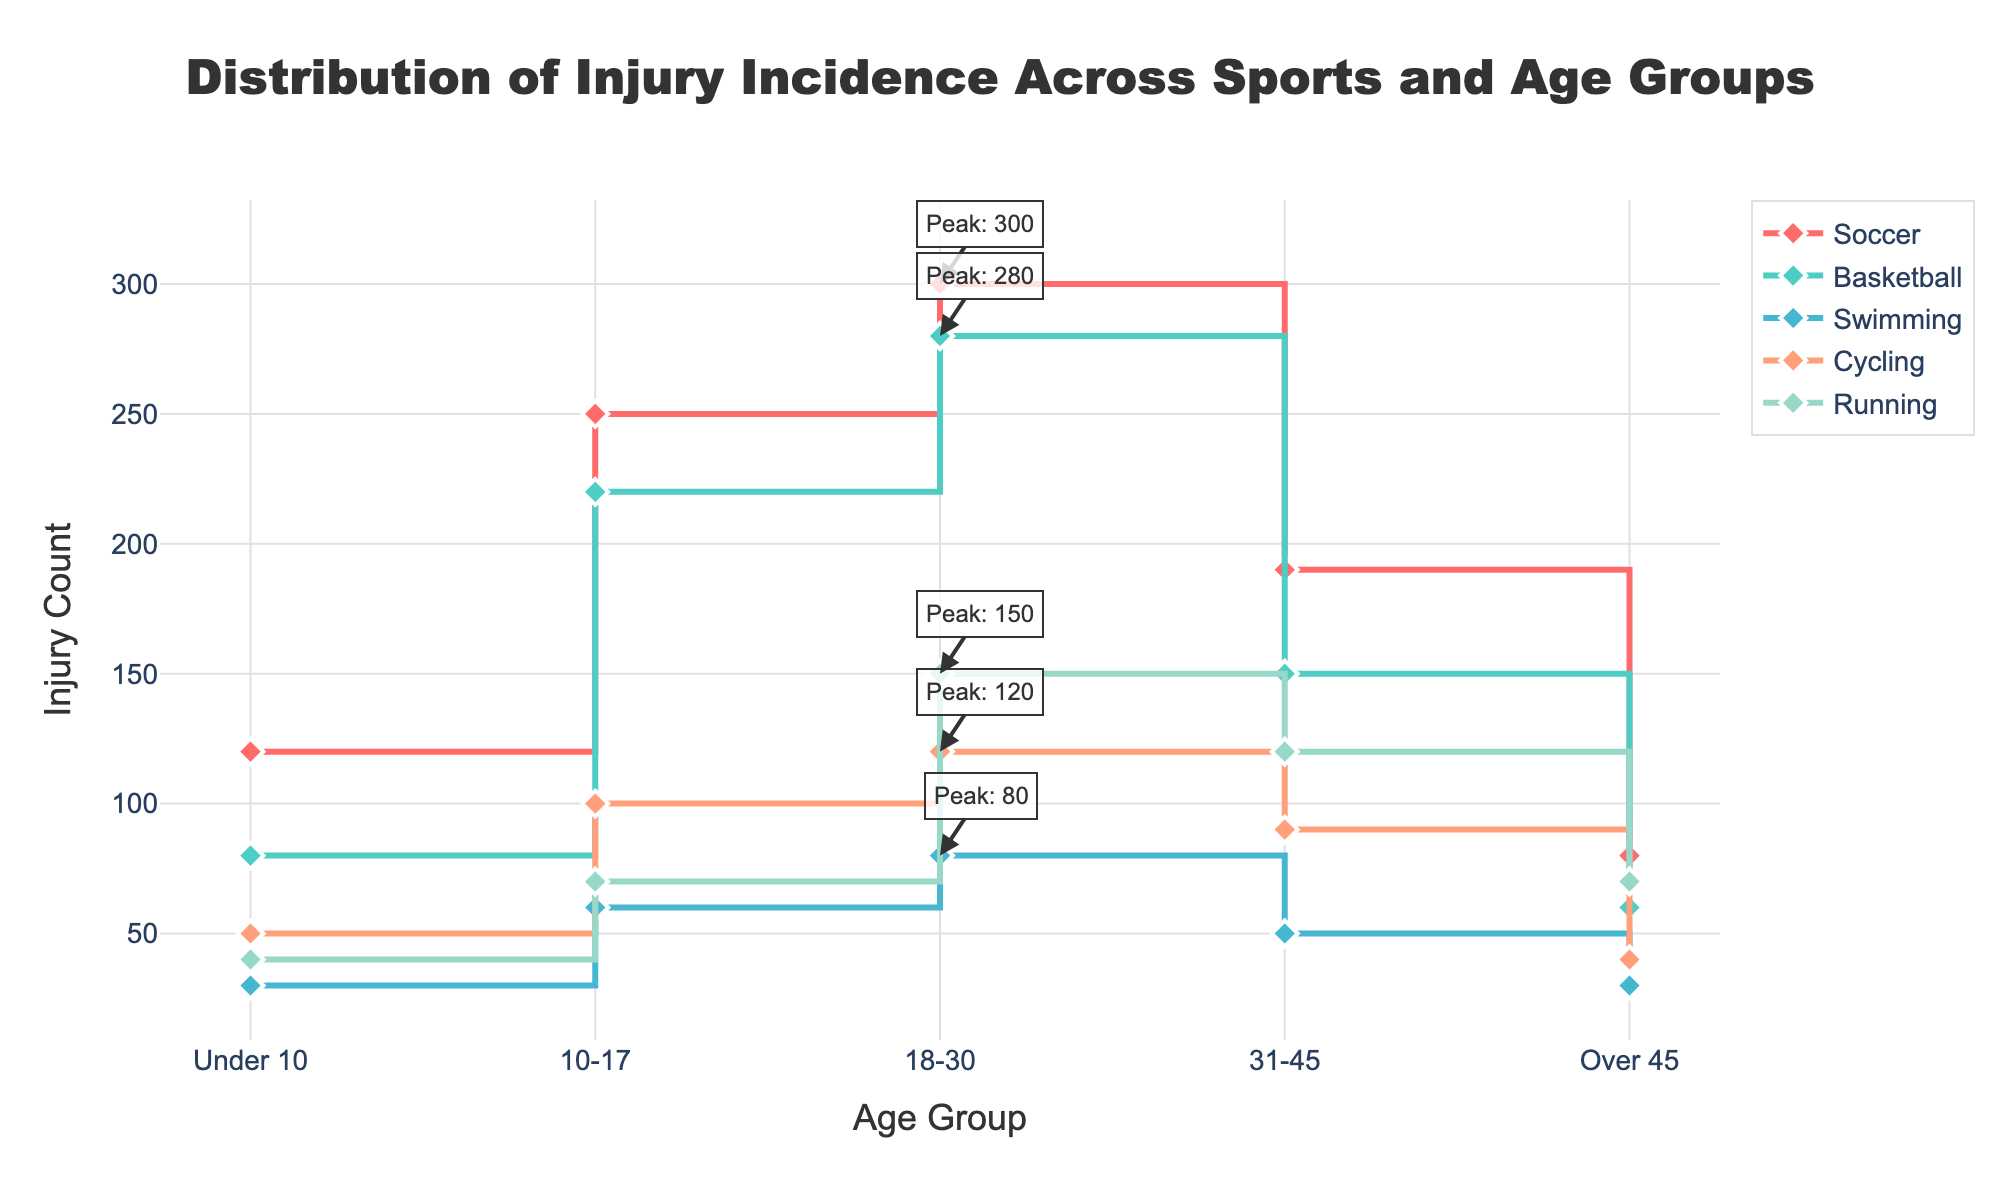What's the title of the figure? The title is located at the top of the figure in a slightly larger and bold font.
Answer: Distribution of Injury Incidence Across Sports and Age Groups How many age groups are shown on the x-axis? By visually counting the categories along the x-axis, we can see there are five distinct age groups mentioned.
Answer: Five (Under 10, 10-17, 18-30, 31-45, Over 45) Which age group has the highest injury count in Soccer? Looking at the stair plot for Soccer, the peak occurs at the age group with the highest marker value. The maximum point is at the 18-30 age group.
Answer: 18-30 What is the difference in injury count between the highest and lowest age groups in Basketball? Find the highest and the lowest points on the Basketball line. The highest count is for age 18-30 with 280 injuries, and the lowest is for age Over 45 with 60 injuries. The difference is 280 - 60.
Answer: 220 Which sport has the highest peak injury count and in which age group does it occur? Examine all the peaks marked with "Peak" annotations. The sport with the highest number is Soccer at the 18-30 age group with 300 injuries.
Answer: Soccer, 18-30 Between Swimming and Cycling, which sport shows a decline in injury count moving from age 10-17 to 18-30? Compare the injury counts for the 10-17 and 18-30 for both sports: Swimming increases from 60 to 80, while Cycling also increases from 100 to 120. Neither shows a decline.
Answer: Neither How does the injury count trend for Running from age group Under 10 to Over 45? By tracing the Running line plot across all age groups starting from Under 10 to Over 45, observe the trend: 40, 70, 150, 120, 70 shows an increase in early age groups, peaks at 18-30, then declines.
Answer: Increase, peak, then decline Which sport has the lowest injury count in the Under 10 age group? Examine the markers at the Under 10 age group. Swimming has the lowest count with 30 injuries.
Answer: Swimming What is the average injury count for Swimming across all age groups? Sum the injury counts for all age groups in Swimming (30 + 60 + 80 + 50 + 30) and divide by the number of groups (5), which is (30+60+80+50+30)/5.
Answer: 50 injuries If we combine the injury counts of all sports for the 31-45 age group, what is the total injury count? Sum the injury counts for each sport in the 31-45 age group: Soccer (190) + Basketball (150) + Swimming (50) + Cycling (90) + Running (120). The total is 190 + 150 + 50 + 90 + 120.
Answer: 600 